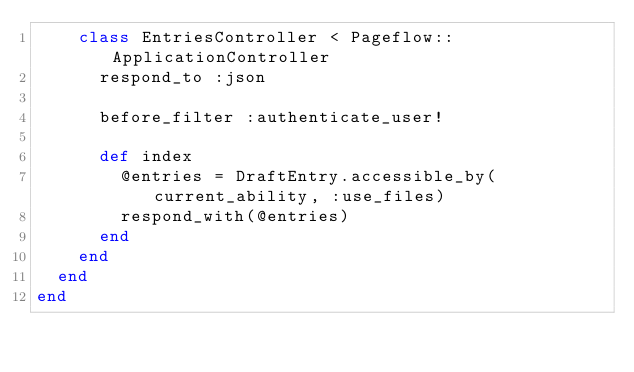<code> <loc_0><loc_0><loc_500><loc_500><_Ruby_>    class EntriesController < Pageflow::ApplicationController
      respond_to :json

      before_filter :authenticate_user!

      def index
        @entries = DraftEntry.accessible_by(current_ability, :use_files)
        respond_with(@entries)
      end
    end
  end
end
</code> 